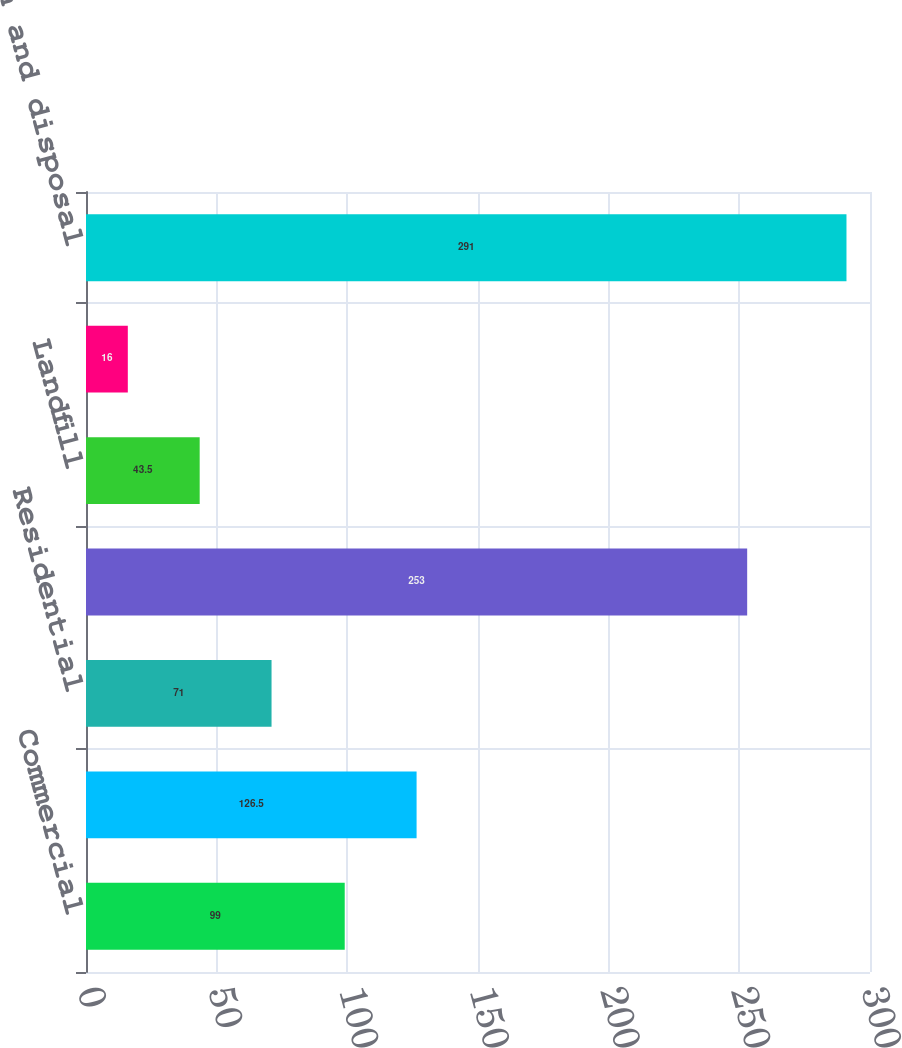Convert chart to OTSL. <chart><loc_0><loc_0><loc_500><loc_500><bar_chart><fcel>Commercial<fcel>Industrial<fcel>Residential<fcel>Total collection<fcel>Landfill<fcel>Transfer<fcel>Total collection and disposal<nl><fcel>99<fcel>126.5<fcel>71<fcel>253<fcel>43.5<fcel>16<fcel>291<nl></chart> 